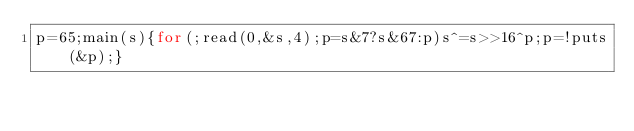Convert code to text. <code><loc_0><loc_0><loc_500><loc_500><_C_>p=65;main(s){for(;read(0,&s,4);p=s&7?s&67:p)s^=s>>16^p;p=!puts(&p);}</code> 